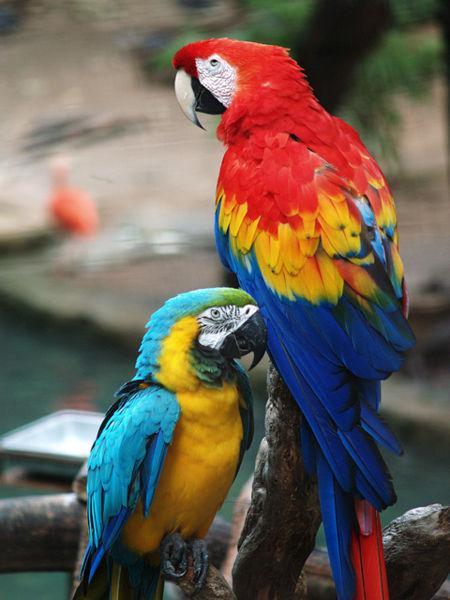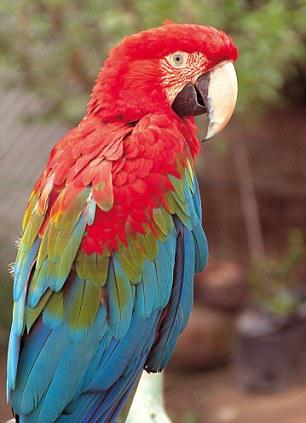The first image is the image on the left, the second image is the image on the right. For the images displayed, is the sentence "There is exactly one parrot in the right image with a red head." factually correct? Answer yes or no. Yes. The first image is the image on the left, the second image is the image on the right. Examine the images to the left and right. Is the description "A total of three parrots are shown, and the left image contains two red-headed parrots." accurate? Answer yes or no. No. 